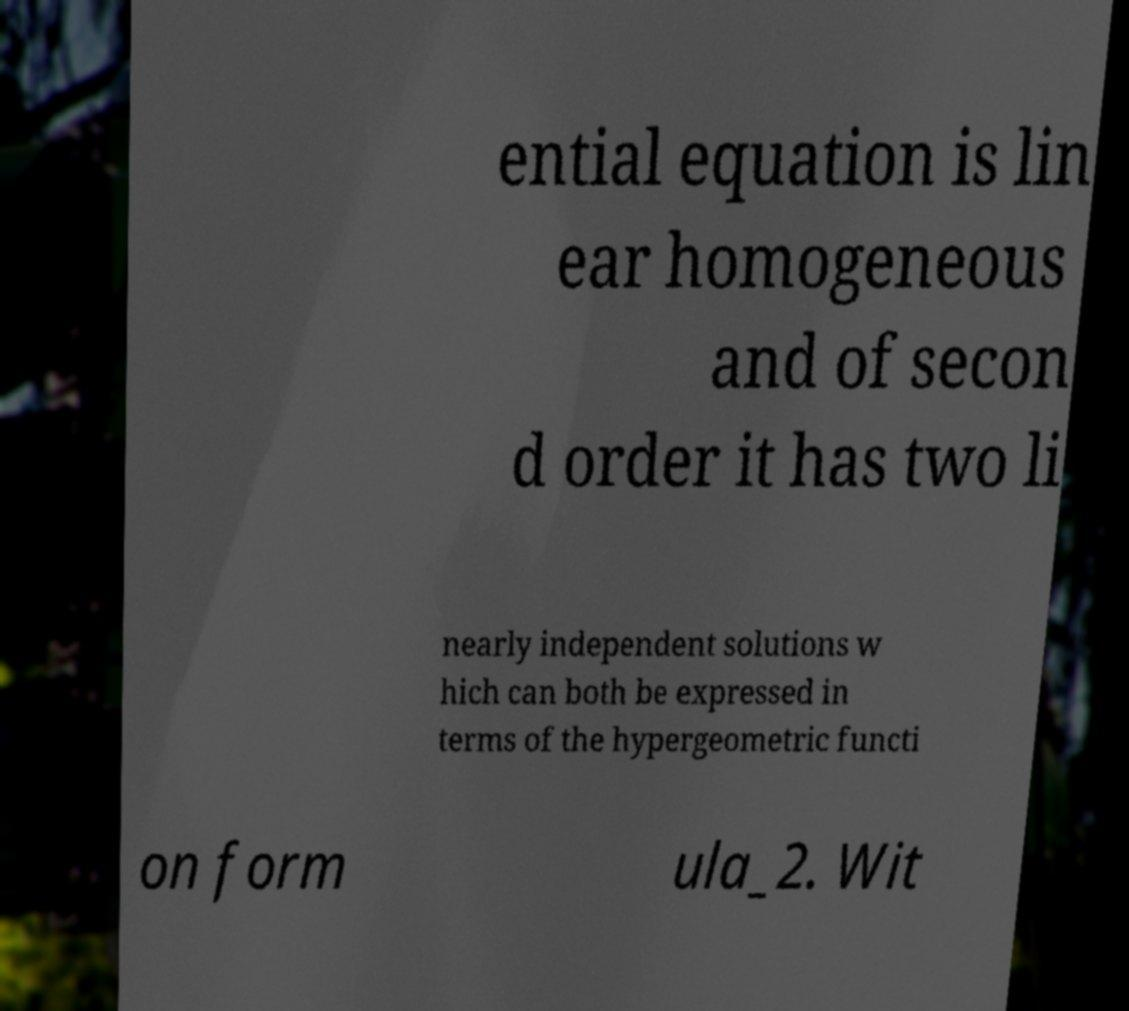Please identify and transcribe the text found in this image. ential equation is lin ear homogeneous and of secon d order it has two li nearly independent solutions w hich can both be expressed in terms of the hypergeometric functi on form ula_2. Wit 